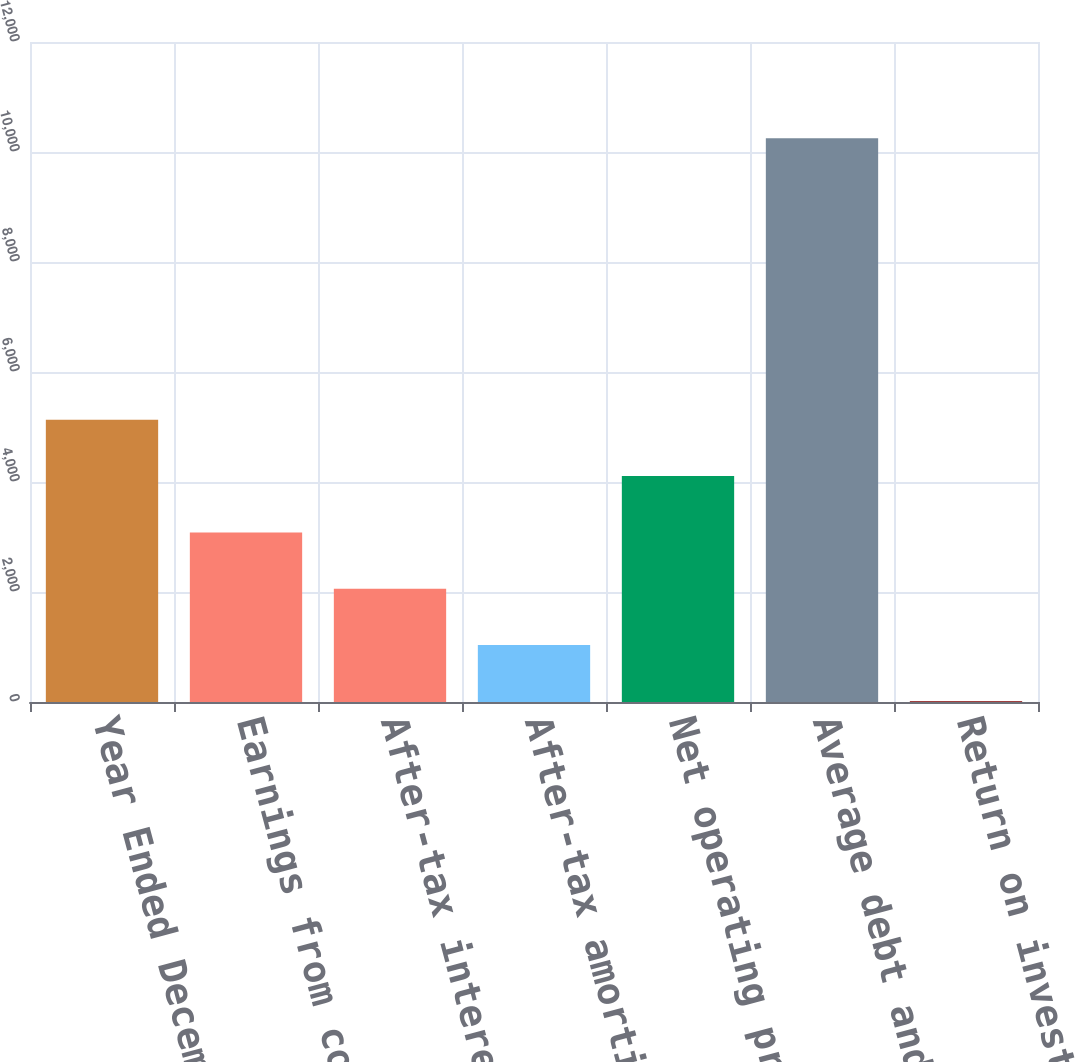Convert chart. <chart><loc_0><loc_0><loc_500><loc_500><bar_chart><fcel>Year Ended December 31<fcel>Earnings from continuing<fcel>After-tax interest expense<fcel>After-tax amortization expense<fcel>Net operating profit after<fcel>Average debt and equity<fcel>Return on invested capital<nl><fcel>5131.15<fcel>3084.01<fcel>2060.44<fcel>1036.87<fcel>4107.58<fcel>10249<fcel>13.3<nl></chart> 